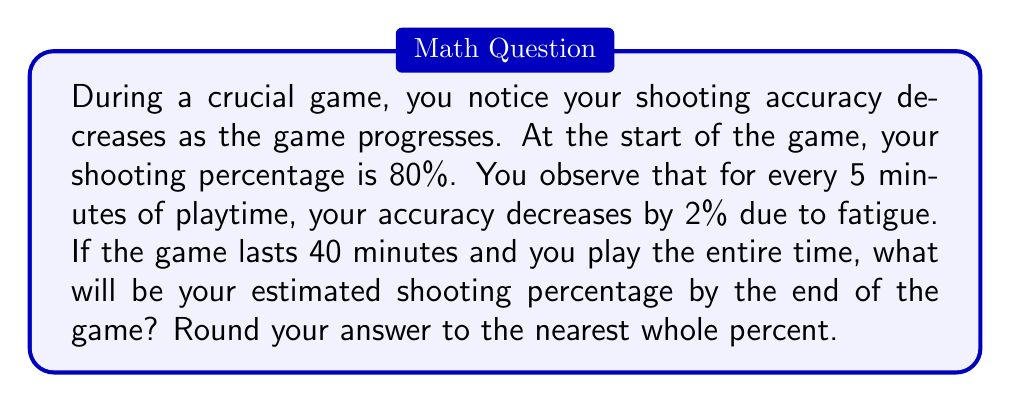Could you help me with this problem? Let's approach this step-by-step:

1) Initial shooting percentage: 80%

2) Decrease in accuracy: 2% every 5 minutes

3) Total game time: 40 minutes

4) Number of 5-minute intervals in 40 minutes:
   $$\frac{40 \text{ minutes}}{5 \text{ minutes/interval}} = 8 \text{ intervals}$$

5) Total decrease in accuracy:
   $$8 \text{ intervals} \times 2\% \text{ per interval} = 16\%$$

6) Final shooting percentage:
   $$80\% - 16\% = 64\%$$

To visualize this decline, we can use a linear function:

$$f(t) = 80 - 0.4t$$

Where $f(t)$ is the shooting percentage and $t$ is the time in minutes.

[asy]
size(200,200);
import graph;

xaxis("Time (minutes)",0,40,arrow=Arrow);
yaxis("Shooting %",0,100,arrow=Arrow);

real f(real x) {return 80 - 0.4x;}
draw(graph(f,0,40),blue);

dot((0,80),red);
dot((40,64),red);

label("Start (80%)",(0,85),E);
label("End (64%)",(40,69),W);
[/asy]

This graph shows the linear decline in shooting percentage over the course of the game.
Answer: 64% 